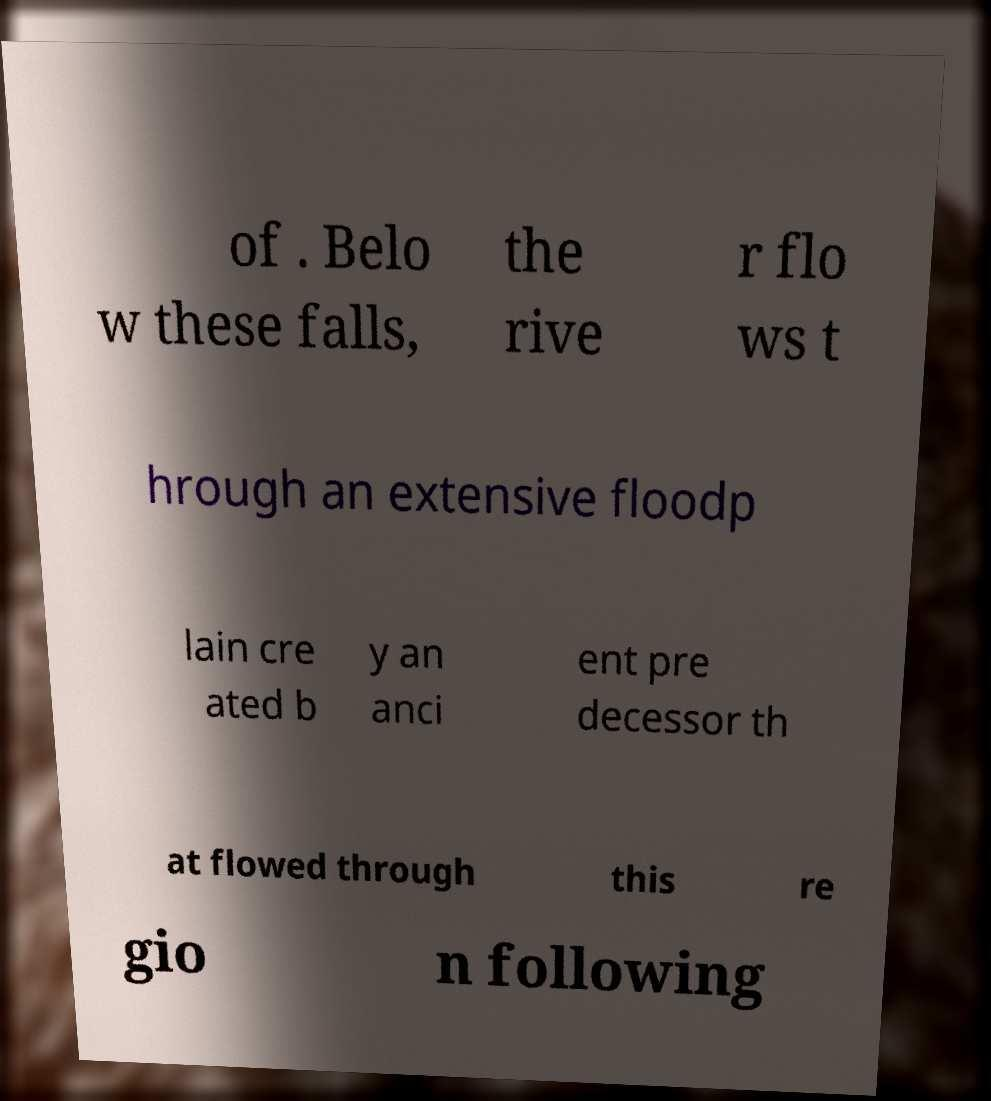Could you assist in decoding the text presented in this image and type it out clearly? of . Belo w these falls, the rive r flo ws t hrough an extensive floodp lain cre ated b y an anci ent pre decessor th at flowed through this re gio n following 